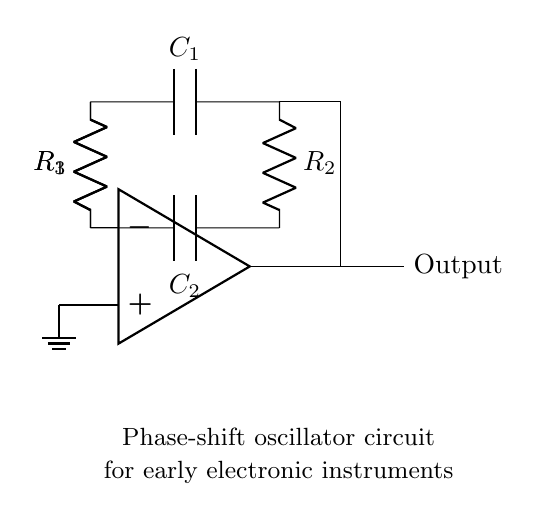What is the role of the op-amp in this circuit? The op-amp serves as the active component that amplifies the voltage and enables feedback, which is crucial for the oscillation to occur in the phase-shift oscillator circuit.
Answer: amplifier What is the value of R1? The circuit diagram labels R1, but it does not specify a numerical value. Thus, it remains an undefined variable within this context.
Answer: undefined How many resistors are in the circuit? Counting the labeled resistors in the circuit diagram shows a total of three resistors, R1, R2, and R3.
Answer: three What type of oscillator is this circuit? The circuit is labeled explicitly as a phase-shift oscillator, which indicates its specific behavior in generating oscillations based on phase shifts.
Answer: phase-shift How do R2 and C1 interact in the circuit? R2 and C1 create a time constant that affects the frequency and stability of the oscillation by slowing down the charge and discharge cycles in the oscillator feedback loop.
Answer: time constant What is the function of C2 in this circuit? C2 works in conjunction with R3 to form a part of the feedback loop necessary for establishing the phase conditions required for oscillation.
Answer: feedback component 